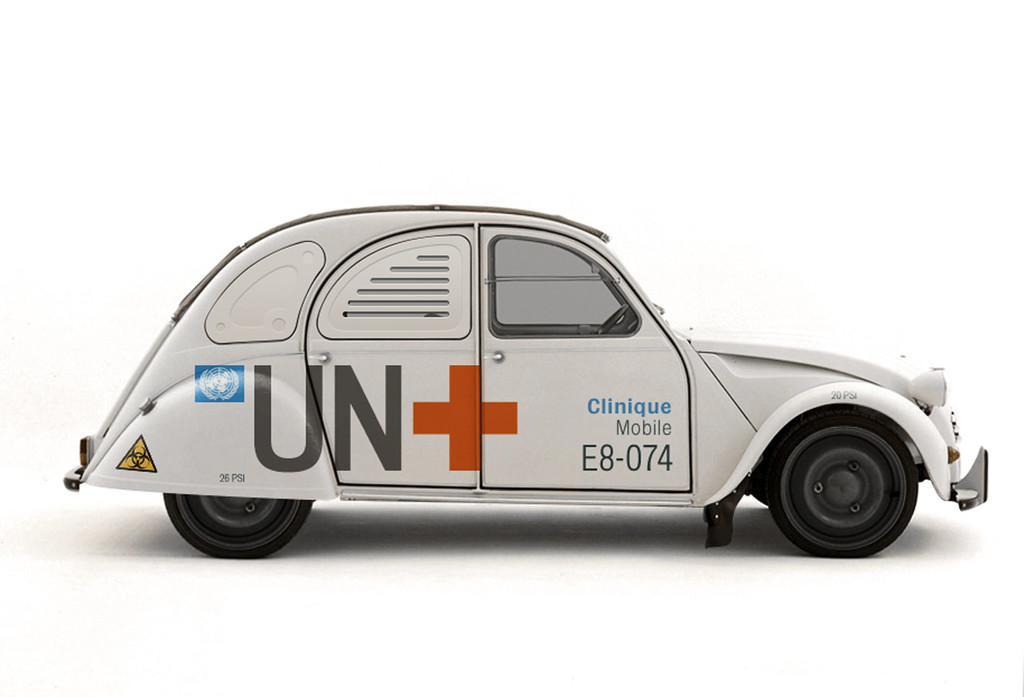In one or two sentences, can you explain what this image depicts? In this picture we can see a vehicle and on this vehicle we can see some symbols and text. 